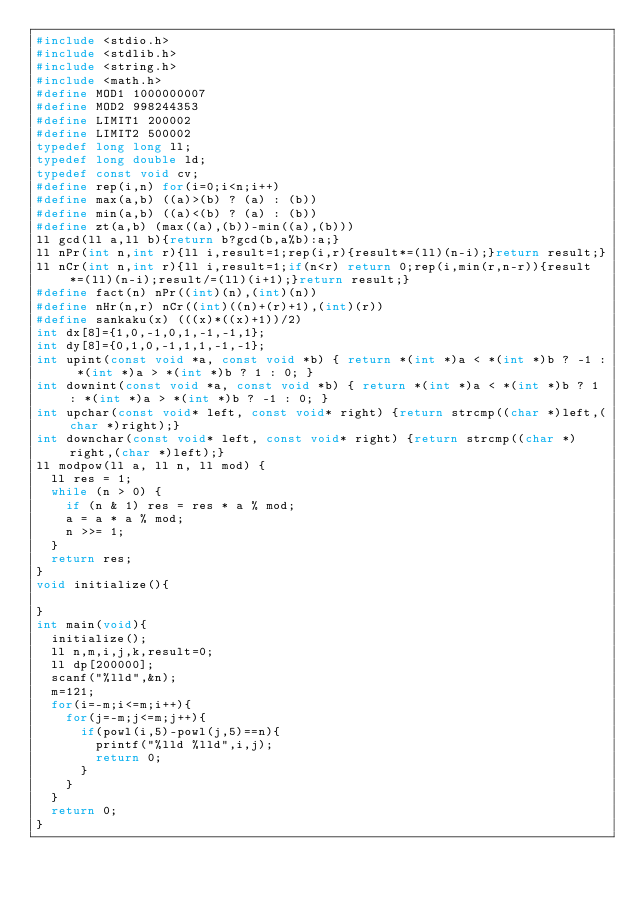<code> <loc_0><loc_0><loc_500><loc_500><_C_>#include <stdio.h>
#include <stdlib.h>
#include <string.h>
#include <math.h>
#define MOD1 1000000007
#define MOD2 998244353
#define LIMIT1 200002
#define LIMIT2 500002
typedef long long ll;
typedef long double ld;
typedef const void cv;
#define rep(i,n) for(i=0;i<n;i++)
#define max(a,b) ((a)>(b) ? (a) : (b))
#define min(a,b) ((a)<(b) ? (a) : (b))
#define zt(a,b) (max((a),(b))-min((a),(b)))
ll gcd(ll a,ll b){return b?gcd(b,a%b):a;}
ll nPr(int n,int r){ll i,result=1;rep(i,r){result*=(ll)(n-i);}return result;}
ll nCr(int n,int r){ll i,result=1;if(n<r) return 0;rep(i,min(r,n-r)){result*=(ll)(n-i);result/=(ll)(i+1);}return result;}
#define fact(n) nPr((int)(n),(int)(n))
#define nHr(n,r) nCr((int)((n)+(r)+1),(int)(r))
#define sankaku(x) (((x)*((x)+1))/2)
int dx[8]={1,0,-1,0,1,-1,-1,1};
int dy[8]={0,1,0,-1,1,1,-1,-1};
int upint(const void *a, const void *b) { return *(int *)a < *(int *)b ? -1 : *(int *)a > *(int *)b ? 1 : 0; }
int downint(const void *a, const void *b) { return *(int *)a < *(int *)b ? 1 : *(int *)a > *(int *)b ? -1 : 0; }
int upchar(const void* left, const void* right) {return strcmp((char *)left,(char *)right);}
int downchar(const void* left, const void* right) {return strcmp((char *)right,(char *)left);}
ll modpow(ll a, ll n, ll mod) {
  ll res = 1;
  while (n > 0) {
    if (n & 1) res = res * a % mod;
    a = a * a % mod;
    n >>= 1;
  }
  return res;
}
void initialize(){
    
}
int main(void){
  initialize();
  ll n,m,i,j,k,result=0;
  ll dp[200000];
  scanf("%lld",&n);
  m=121;
  for(i=-m;i<=m;i++){
    for(j=-m;j<=m;j++){
      if(powl(i,5)-powl(j,5)==n){
        printf("%lld %lld",i,j);
        return 0;
      }
    }
  }
  return 0;
}

</code> 